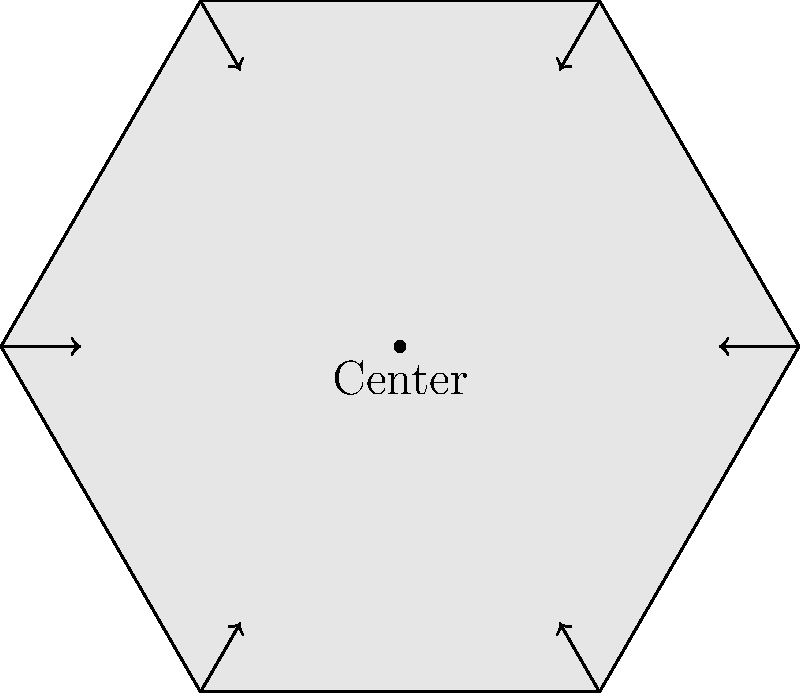The floor plan of a newly proposed local government building in your municipality has a hexagonal shape, as shown in the diagram. How many rotational symmetries does this floor plan have? To determine the number of rotational symmetries in a hexagonal floor plan, we need to follow these steps:

1. Understand rotational symmetry: A shape has rotational symmetry if it can be rotated around its center by a certain angle and still look the same.

2. Identify the order of rotational symmetry: For a regular hexagon, we need to find how many times we can rotate it before it returns to its original position.

3. Calculate the rotations:
   - A full rotation is 360°
   - The smallest rotation that brings the hexagon back to its original position is 60° (360° ÷ 6)
   - The possible rotations are:
     a) 60° (1/6 of a full rotation)
     b) 120° (2/6 of a full rotation)
     c) 180° (3/6 of a full rotation)
     d) 240° (4/6 of a full rotation)
     e) 300° (5/6 of a full rotation)
     f) 360° (6/6 of a full rotation, back to the starting position)

4. Count the symmetries: In addition to the rotations listed above, we also count the original position (0° rotation) as a symmetry.

Therefore, the total number of rotational symmetries is 6 (the rotations listed above) + 1 (the original position) = 7.
Answer: 7 